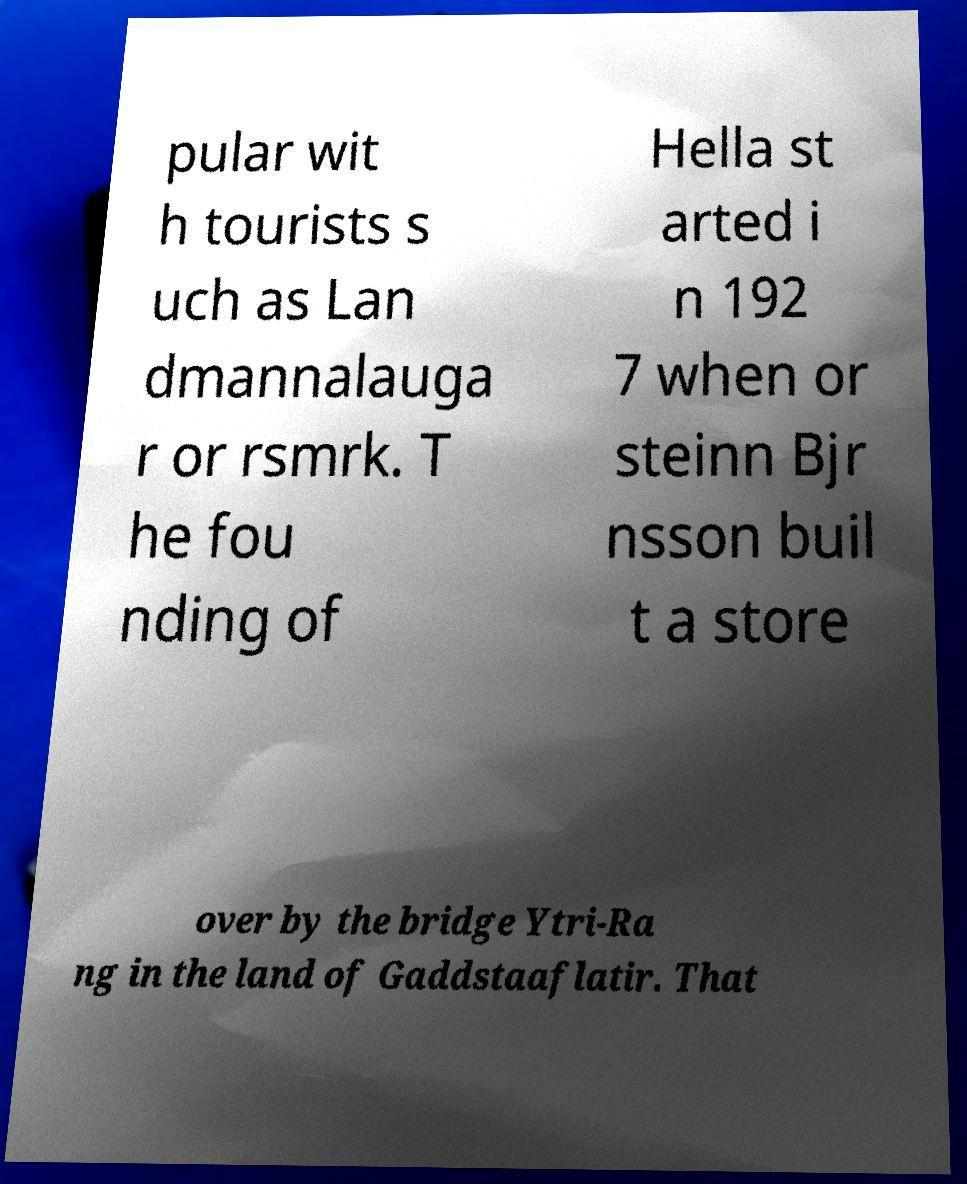Could you assist in decoding the text presented in this image and type it out clearly? pular wit h tourists s uch as Lan dmannalauga r or rsmrk. T he fou nding of Hella st arted i n 192 7 when or steinn Bjr nsson buil t a store over by the bridge Ytri-Ra ng in the land of Gaddstaaflatir. That 